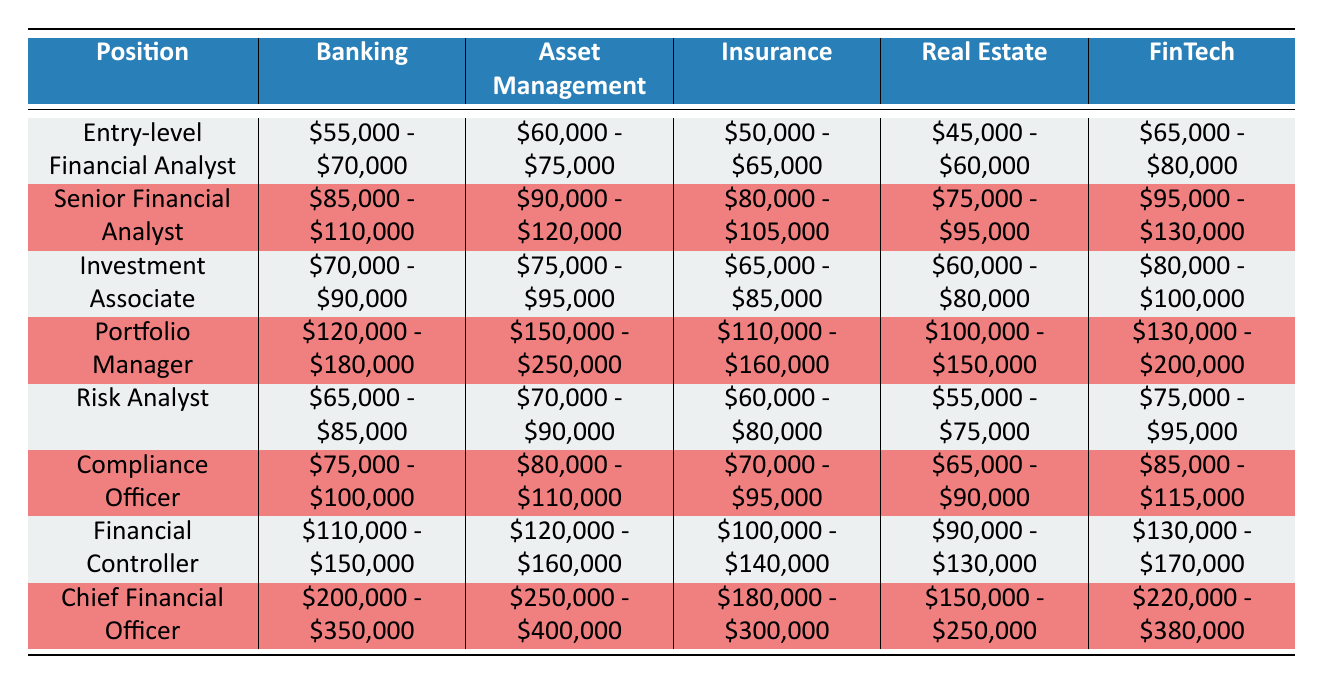What is the salary range for an Entry-level Financial Analyst in the FinTech industry? The table indicates that the salary range for an Entry-level Financial Analyst in the FinTech sector is from $65,000 to $80,000. This information is directly found in the FinTech column of the relevant row.
Answer: $65,000 - $80,000 Which position has the highest salary range in Asset Management? By examining the Asset Management column, the position with the highest salary range is the Portfolio Manager, which ranges from $150,000 to $250,000.
Answer: Portfolio Manager Is the salary range for a Compliance Officer in Insurance higher than that in Real Estate? The salary range for a Compliance Officer in Insurance is $70,000 to $95,000, while in Real Estate, it is $65,000 to $90,000. Since $70,000 to $95,000 exceeds $65,000 to $90,000, the statement is true.
Answer: Yes What is the average salary range for Senior Financial Analysts across all industries? To calculate the average, we first note the ranges: Banking ($85,000 - $110,000), Asset Management ($90,000 - $120,000), Insurance ($80,000 - $105,000), Real Estate ($75,000 - $95,000), and FinTech ($95,000 - $130,000). The averages for each range are $97,500, $105,000, $92,500, $85,000, and $112,500 respectively. Summing these gives $492,500, and dividing by 5 gives an average of $98,500.
Answer: $98,500 Is it false that a Financial Controller earns more in the Banking industry than in FinTech? The salary range for a Financial Controller in Banking is $110,000 to $150,000, and in FinTech, it is $130,000 to $170,000. Since the Banking range is lower than the FinTech range, the statement is false.
Answer: False 